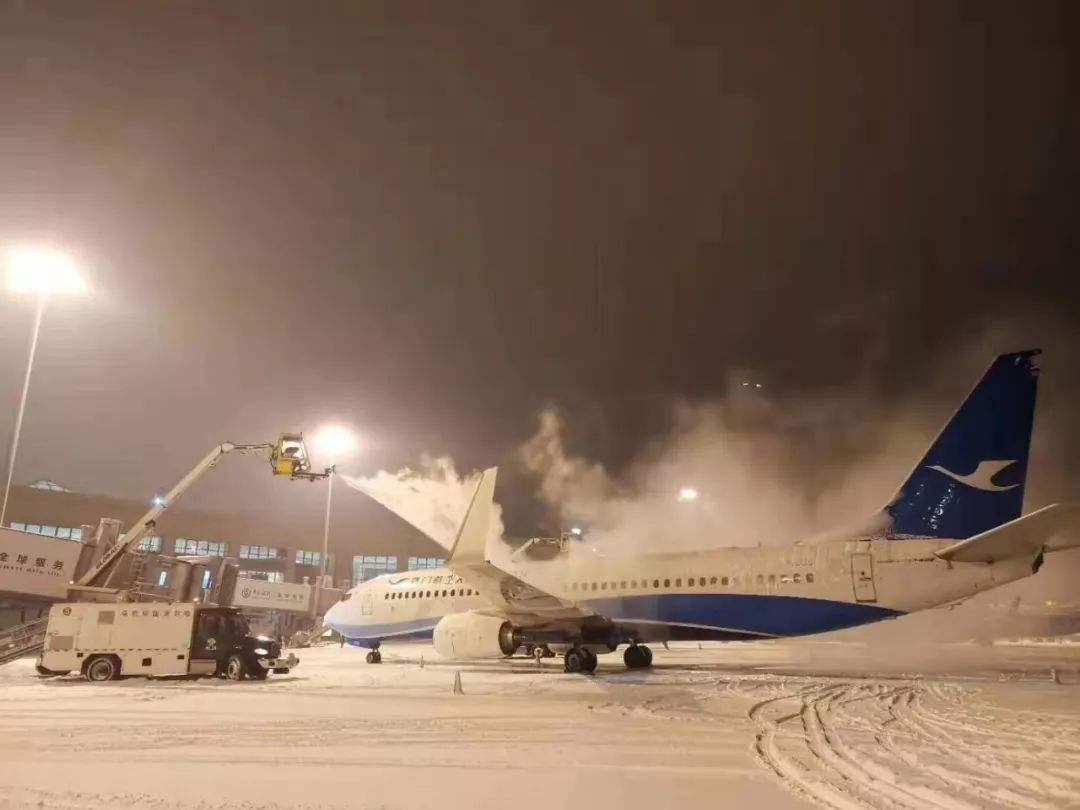How many aeroplanes are there in the image? There is one airplane visible in the image, captured during a nighttime de-icing operation, a crucial safety measure to ensure the aircraft's surfaces are clear of ice and snow. 